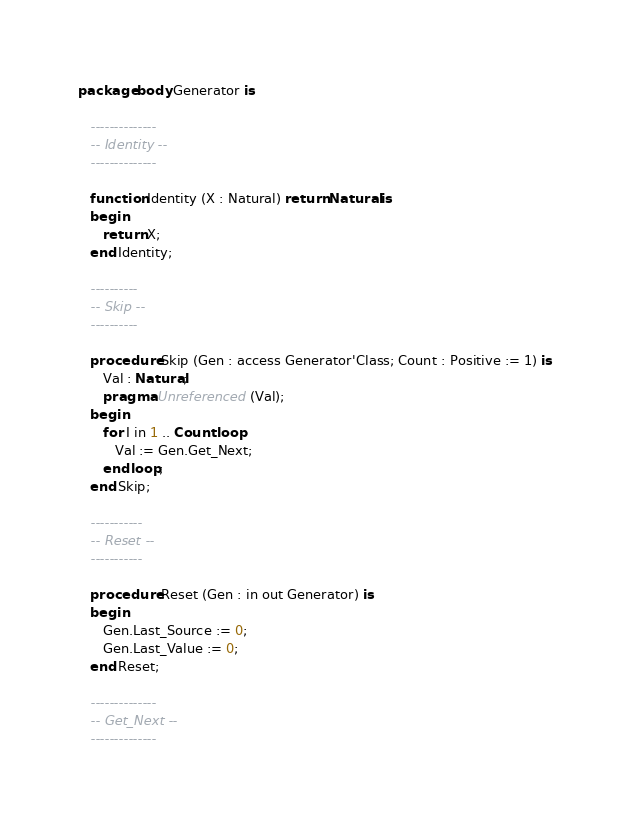<code> <loc_0><loc_0><loc_500><loc_500><_Ada_>package body Generator is

   --------------
   -- Identity --
   --------------

   function Identity (X : Natural) return Natural is
   begin
      return X;
   end Identity;

   ----------
   -- Skip --
   ----------

   procedure Skip (Gen : access Generator'Class; Count : Positive := 1) is
      Val : Natural;
      pragma Unreferenced (Val);
   begin
      for I in 1 .. Count loop
         Val := Gen.Get_Next;
      end loop;
   end Skip;

   -----------
   -- Reset --
   -----------

   procedure Reset (Gen : in out Generator) is
   begin
      Gen.Last_Source := 0;
      Gen.Last_Value := 0;
   end Reset;

   --------------
   -- Get_Next --
   --------------
</code> 